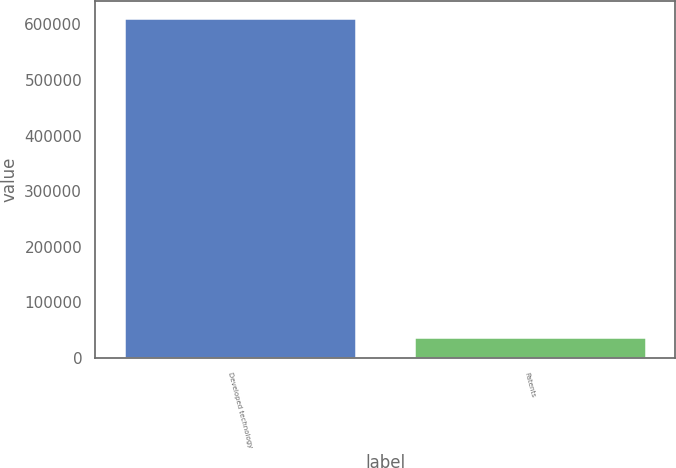Convert chart to OTSL. <chart><loc_0><loc_0><loc_500><loc_500><bar_chart><fcel>Developed technology<fcel>Patents<nl><fcel>610512<fcel>38438<nl></chart> 